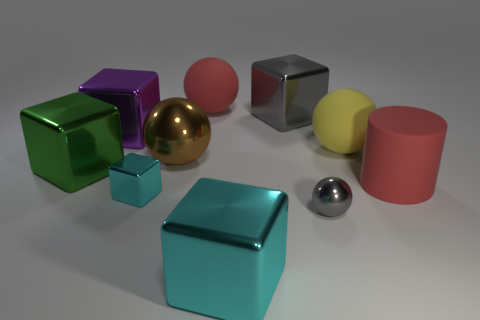Subtract all tiny cyan metallic cubes. How many cubes are left? 4 Subtract all gray balls. How many balls are left? 3 Subtract 0 green cylinders. How many objects are left? 10 Subtract all cylinders. How many objects are left? 9 Subtract 1 cylinders. How many cylinders are left? 0 Subtract all brown blocks. Subtract all cyan balls. How many blocks are left? 5 Subtract all cyan spheres. How many brown cubes are left? 0 Subtract all big red matte spheres. Subtract all purple shiny objects. How many objects are left? 8 Add 1 big red rubber balls. How many big red rubber balls are left? 2 Add 1 large blue metallic spheres. How many large blue metallic spheres exist? 1 